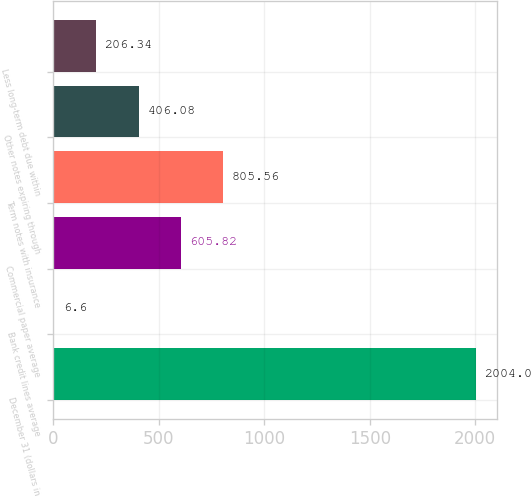Convert chart to OTSL. <chart><loc_0><loc_0><loc_500><loc_500><bar_chart><fcel>December 31 (dollars in<fcel>Bank credit lines average<fcel>Commercial paper average<fcel>Term notes with insurance<fcel>Other notes expiring through<fcel>Less long-term debt due within<nl><fcel>2004<fcel>6.6<fcel>605.82<fcel>805.56<fcel>406.08<fcel>206.34<nl></chart> 